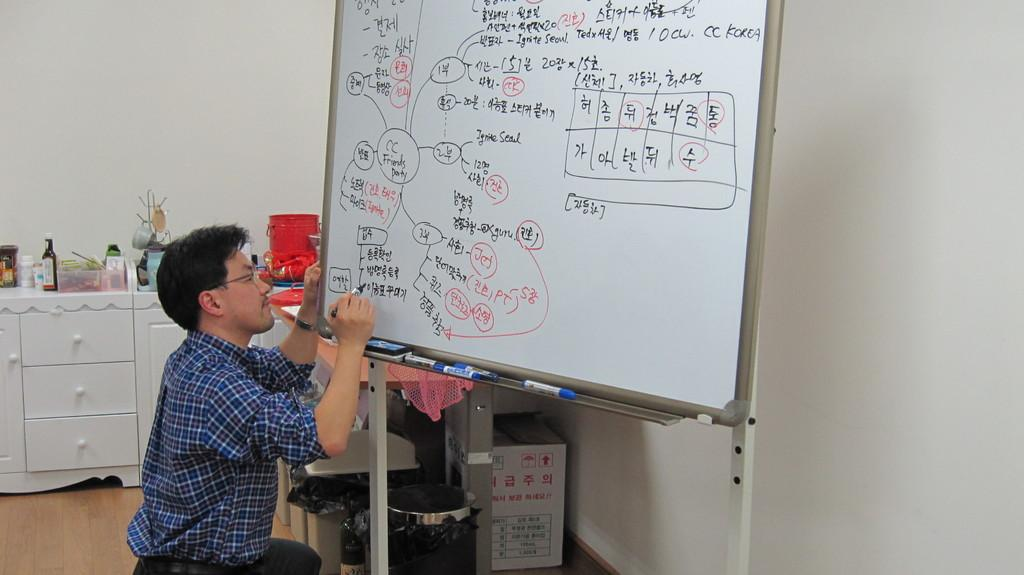<image>
Relay a brief, clear account of the picture shown. A man is writing on a whiteboard with the words 'CC Friends Party' circled. 